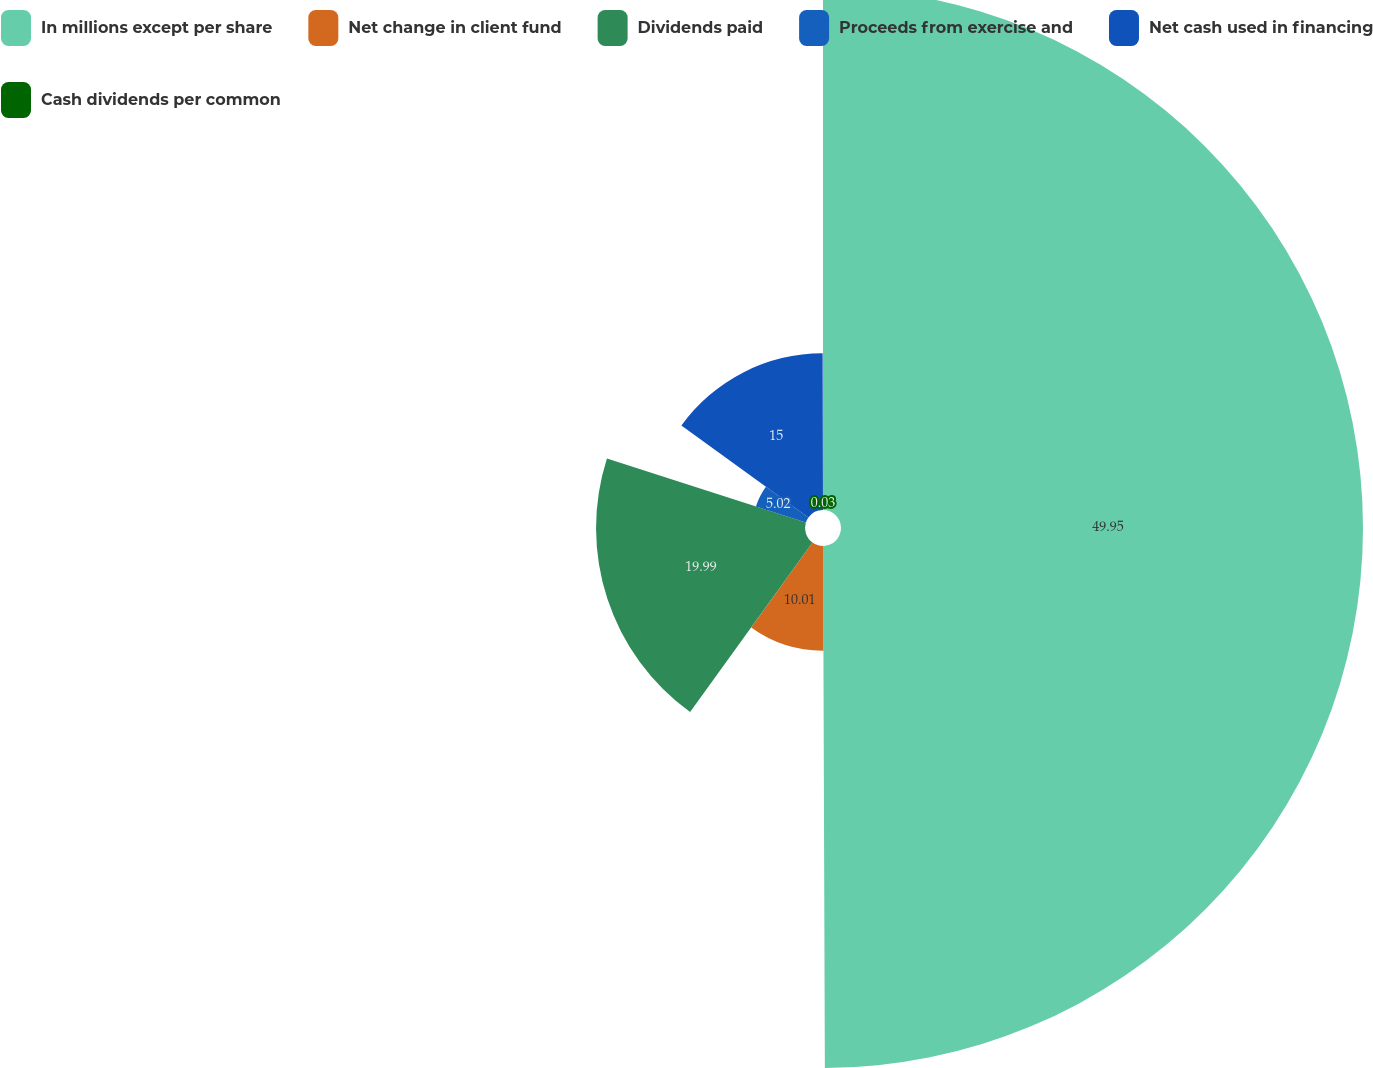<chart> <loc_0><loc_0><loc_500><loc_500><pie_chart><fcel>In millions except per share<fcel>Net change in client fund<fcel>Dividends paid<fcel>Proceeds from exercise and<fcel>Net cash used in financing<fcel>Cash dividends per common<nl><fcel>49.94%<fcel>10.01%<fcel>19.99%<fcel>5.02%<fcel>15.0%<fcel>0.03%<nl></chart> 